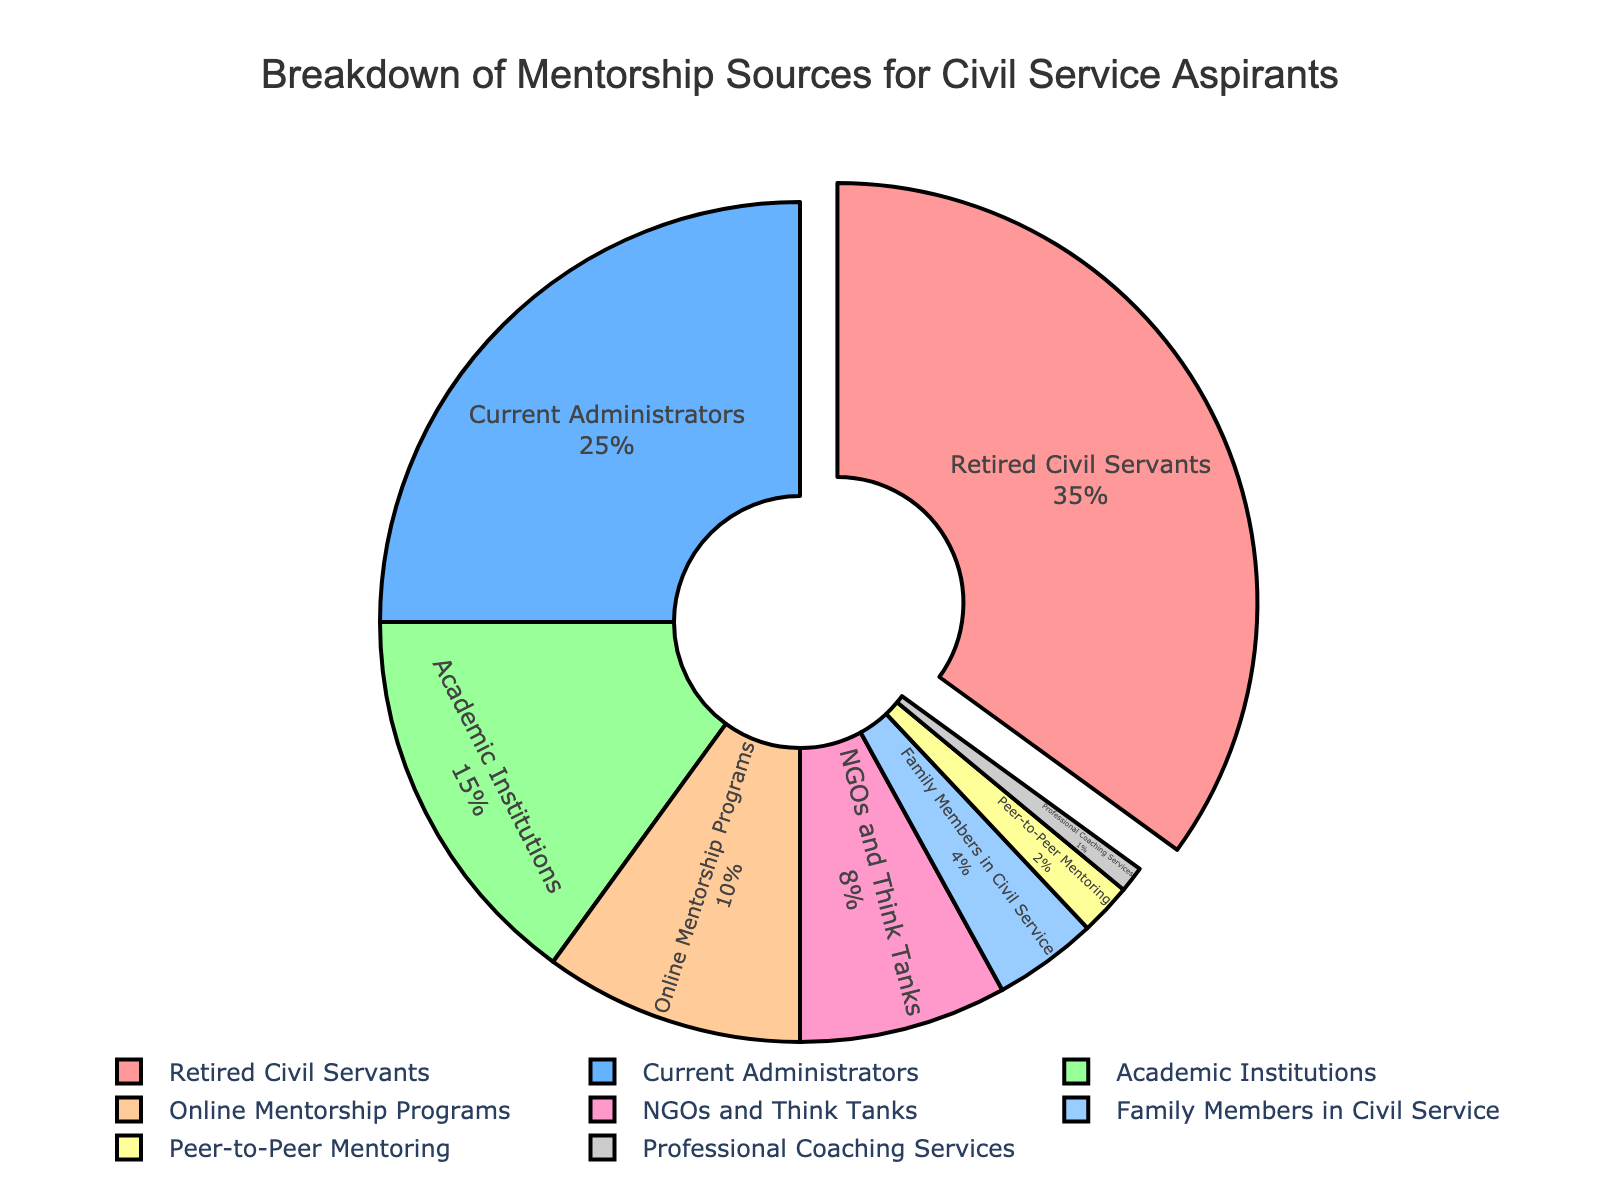What percentage of mentorship comes from retired civil servants? Start by identifying the segment labeled 'Retired Civil Servants'. The percentage noted for this segment is 35%.
Answer: 35% Which mentorship source contributes less than 5%? Look for segments with percentages less than 5%. 'Family Members in Civil Service' and 'Peer-to-Peer Mentoring' both contribute less than 5%, with their percentages being 4% and 2% respectively.
Answer: Family Members in Civil Service, Peer-to-Peer Mentoring What is the difference in mentorship percentage between current administrators and professional coaching services? Find the percentages for 'Current Administrators' (25%) and 'Professional Coaching Services' (1%). Subtract to find the difference: 25% - 1% = 24%.
Answer: 24% Which source has the highest percentage of mentorship? Find the largest percentage value. The 'Retired Civil Servants' segment shows the highest percentage at 35%.
Answer: Retired Civil Servants If we combine the percentages of NGOs and think tanks, peer-to-peer mentoring, and professional coaching services, what is the total percentage? Add the percentages for 'NGOs and Think Tanks' (8%), 'Peer-to-Peer Mentoring' (2%), and 'Professional Coaching Services' (1%): 8% + 2% + 1% = 11%.
Answer: 11% How much more percentage of mentorship is obtained from academic institutions compared to family members in civil service? Find the percentages for 'Academic Institutions' (15%) and 'Family Members in Civil Service' (4%). Then, subtract the smaller value from the larger: 15% - 4% = 11%.
Answer: 11% Which mentorship sources together make up more than 50% of the total? Identify the sources and their percentages until their sum exceeds 50%. 'Retired Civil Servants' (35%) and 'Current Administrators' (25%) together make 60%, which is more than 50%.
Answer: Retired Civil Servants, Current Administrators Among the sources labeled, which one has the smallest representation? Look for the smallest percentage value. 'Professional Coaching Services' has the smallest representation at 1%.
Answer: Professional Coaching Services What is the combined percentage of mentorship from non-institutional sources (excluding retired and current civil servants, academic institutions, and online programs)? Sum the percentages for 'NGOs and Think Tanks', 'Family Members in Civil Service', 'Peer-to-Peer Mentoring', and 'Professional Coaching Services': 8% + 4% + 2% + 1% = 15%.
Answer: 15% Which color is associated with the segment representing online mentorship programs? Since the colors are cycled and assigned in order of occurrence, locate the 'Online Mentorship Programs' segment and note its color. The segment is the fourth in order and is represented by an orange shade (fourth color in the list of provided colors).
Answer: Orange 